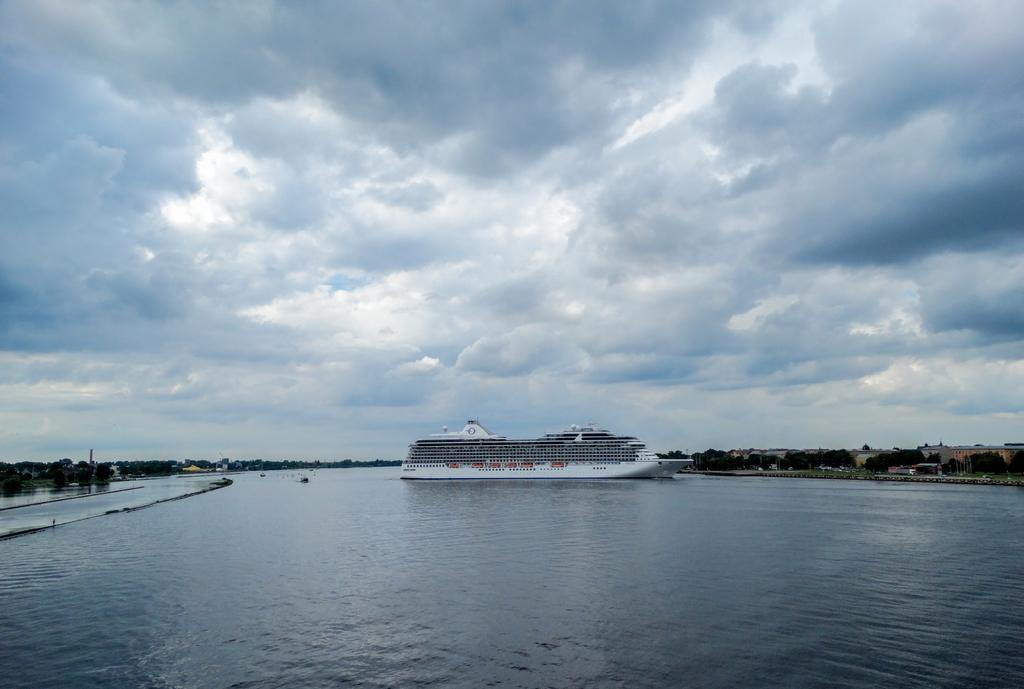What is the main subject of the image? The main subject of the image is a water surface. What is located on the water surface? There is a ship on the water surface. What type of vegetation can be seen in the image? There are trees visible in the image. What is visible in the sky at the top of the image? There are clouds in the sky at the top of the image. Can you tell me how many carts are being pulled by the ship in the image? There are no carts present in the image; the ship is on the water surface. What type of whistle can be heard coming from the trees in the image? There is no whistle present in the image, as the trees are not making any sounds. 